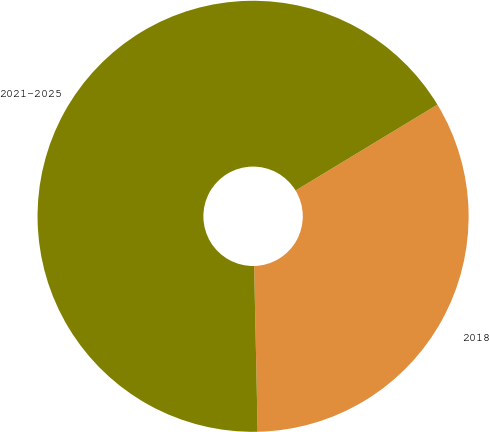<chart> <loc_0><loc_0><loc_500><loc_500><pie_chart><fcel>2018<fcel>2021-2025<nl><fcel>33.33%<fcel>66.67%<nl></chart> 